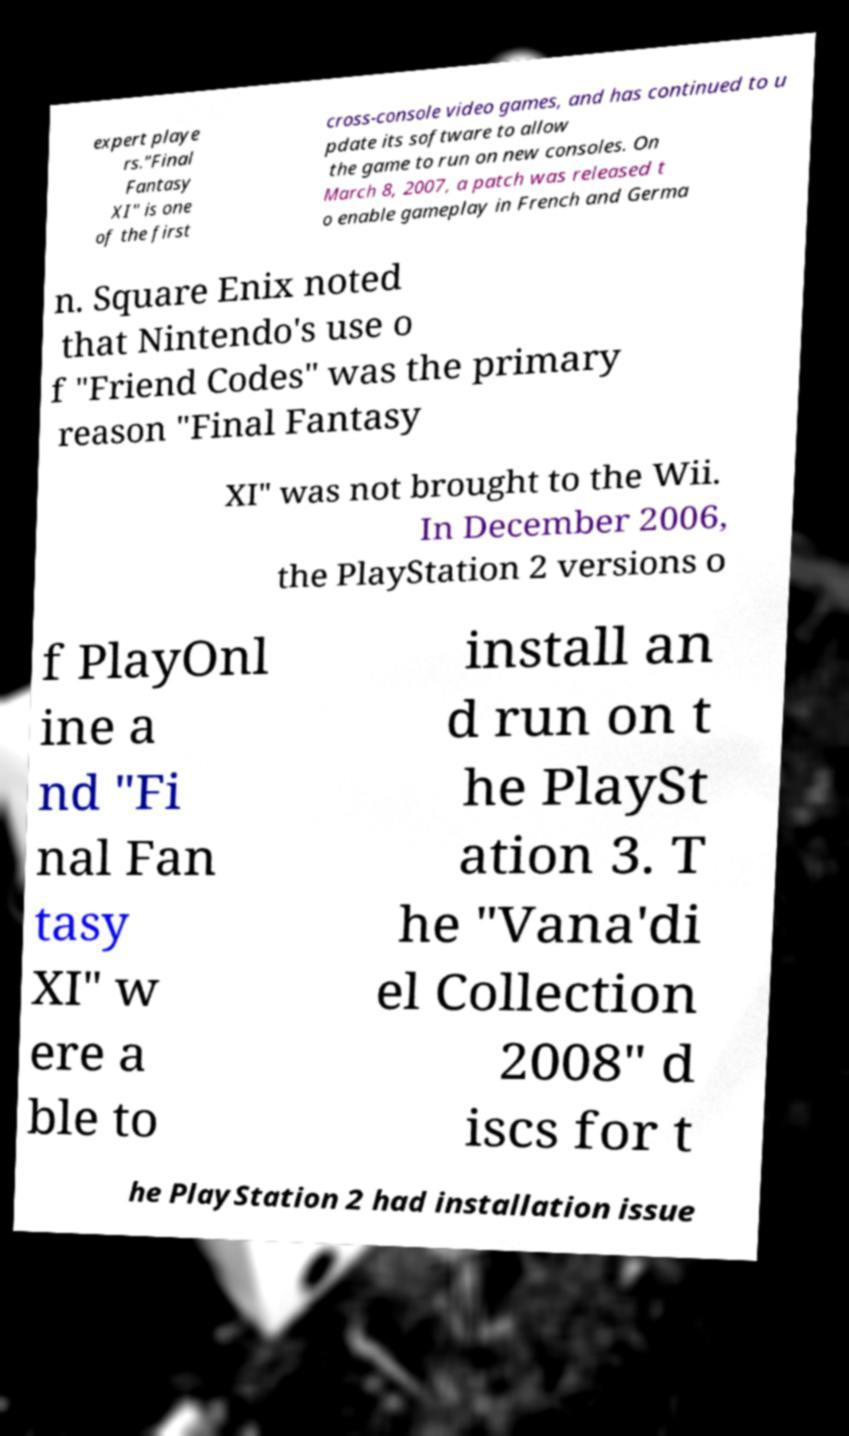What messages or text are displayed in this image? I need them in a readable, typed format. expert playe rs."Final Fantasy XI" is one of the first cross-console video games, and has continued to u pdate its software to allow the game to run on new consoles. On March 8, 2007, a patch was released t o enable gameplay in French and Germa n. Square Enix noted that Nintendo's use o f "Friend Codes" was the primary reason "Final Fantasy XI" was not brought to the Wii. In December 2006, the PlayStation 2 versions o f PlayOnl ine a nd "Fi nal Fan tasy XI" w ere a ble to install an d run on t he PlaySt ation 3. T he "Vana'di el Collection 2008" d iscs for t he PlayStation 2 had installation issue 